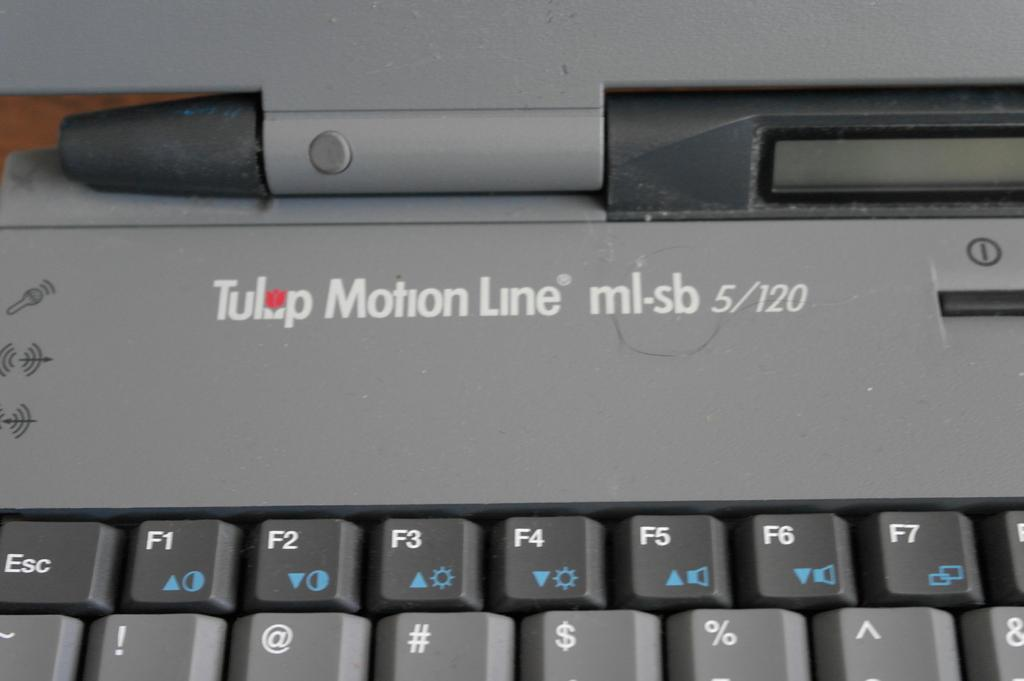<image>
Share a concise interpretation of the image provided. Laptop with the words "Tulip Motion Line" on top. 